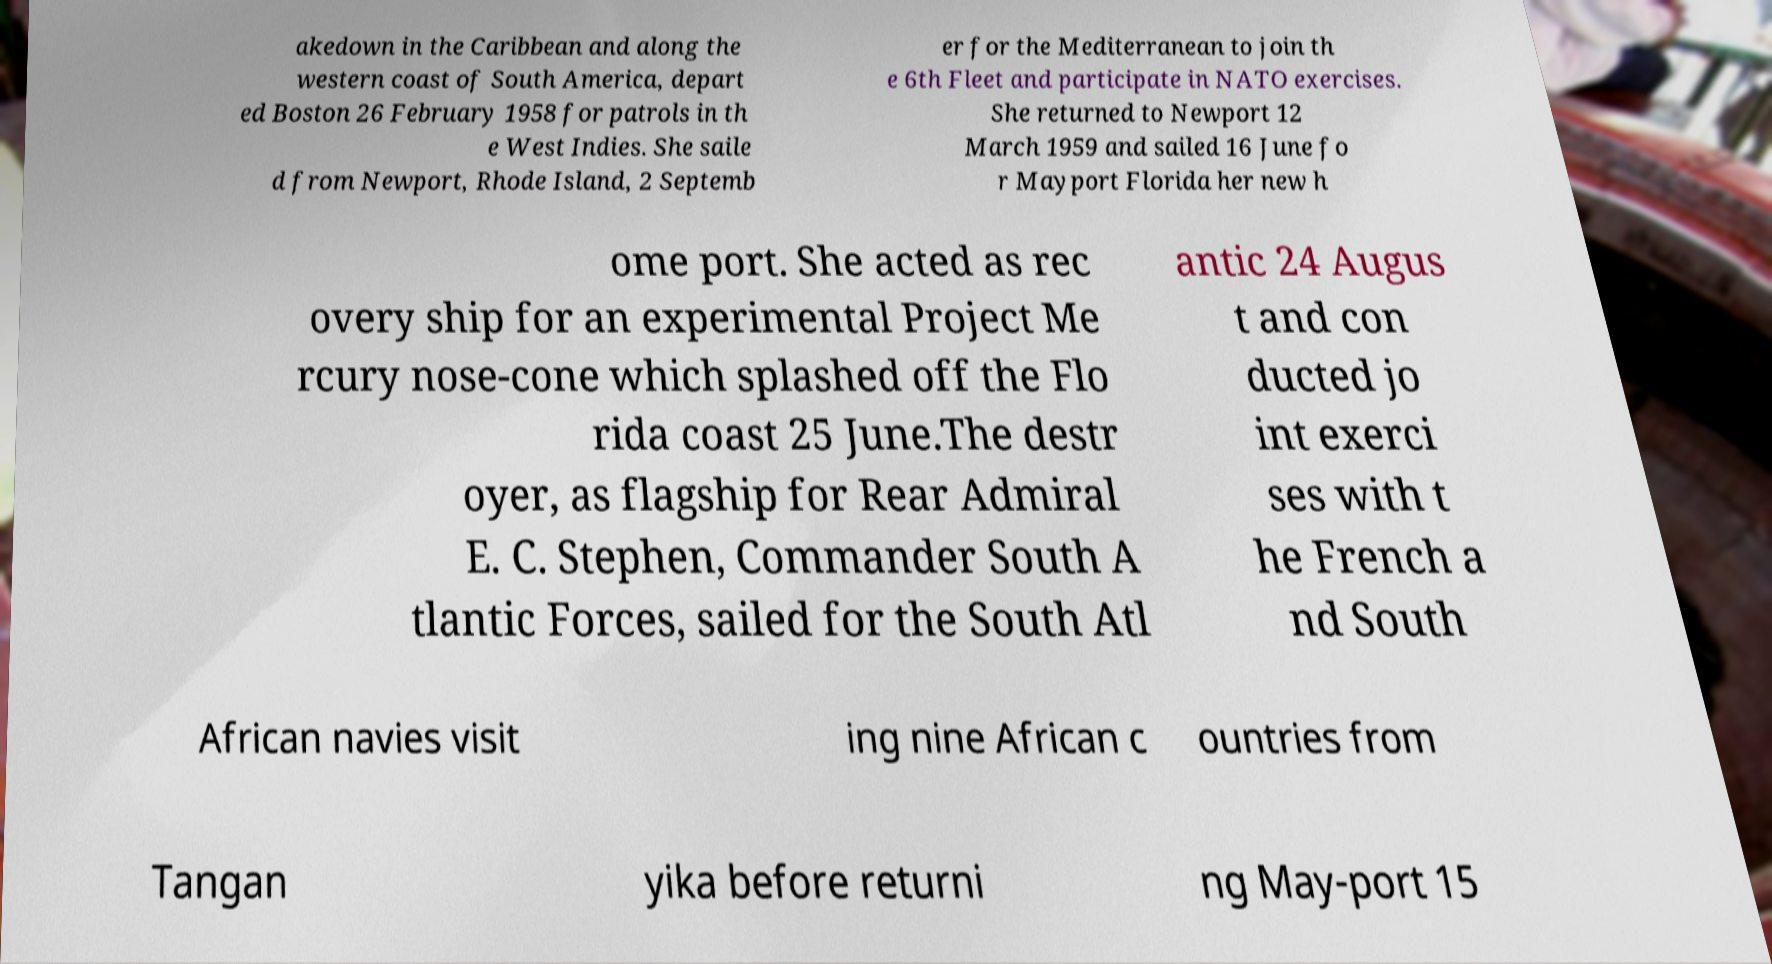There's text embedded in this image that I need extracted. Can you transcribe it verbatim? akedown in the Caribbean and along the western coast of South America, depart ed Boston 26 February 1958 for patrols in th e West Indies. She saile d from Newport, Rhode Island, 2 Septemb er for the Mediterranean to join th e 6th Fleet and participate in NATO exercises. She returned to Newport 12 March 1959 and sailed 16 June fo r Mayport Florida her new h ome port. She acted as rec overy ship for an experimental Project Me rcury nose-cone which splashed off the Flo rida coast 25 June.The destr oyer, as flagship for Rear Admiral E. C. Stephen, Commander South A tlantic Forces, sailed for the South Atl antic 24 Augus t and con ducted jo int exerci ses with t he French a nd South African navies visit ing nine African c ountries from Tangan yika before returni ng May-port 15 